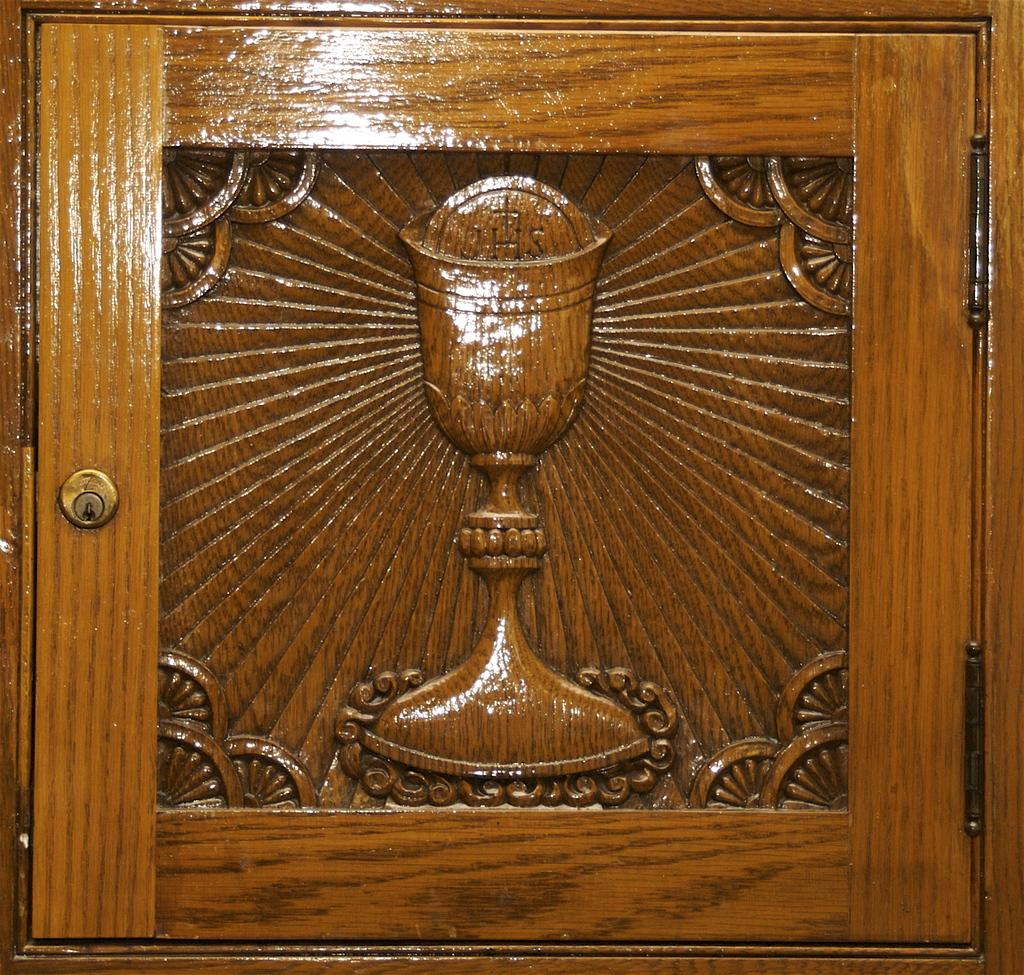What material is the object in the image made of? The object is made of wood. Can you describe the appearance or design of the wooden object? The wooden object is carved. How does the wooden object kick a soccer ball in the image? The wooden object does not kick a soccer ball in the image, as there is no soccer ball or any indication of movement in the image. 